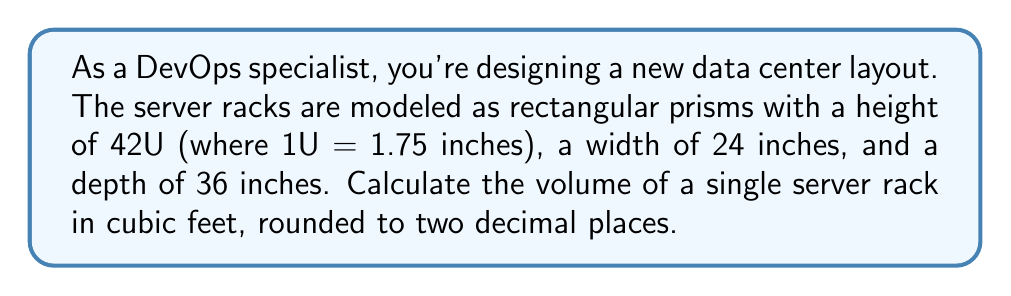Help me with this question. To solve this problem, we'll follow these steps:

1. Convert all measurements to feet:
   Height: $42 \times 1.75$ inches = $73.5$ inches
   $73.5 \div 12 = 6.125$ feet
   
   Width: $24 \div 12 = 2$ feet
   
   Depth: $36 \div 12 = 3$ feet

2. Use the volume formula for a rectangular prism:
   $$V = l \times w \times h$$
   Where $V$ is volume, $l$ is length (depth in this case), $w$ is width, and $h$ is height.

3. Plug in the values:
   $$V = 3 \times 2 \times 6.125$$

4. Calculate the result:
   $$V = 36.75 \text{ cubic feet}$$

5. Round to two decimal places:
   $$V \approx 36.75 \text{ cubic feet}$$

This volume calculation is crucial for DevOps specialists when planning data center layouts, estimating cooling requirements, and optimizing space utilization for server deployments.
Answer: $36.75 \text{ cubic feet}$ 